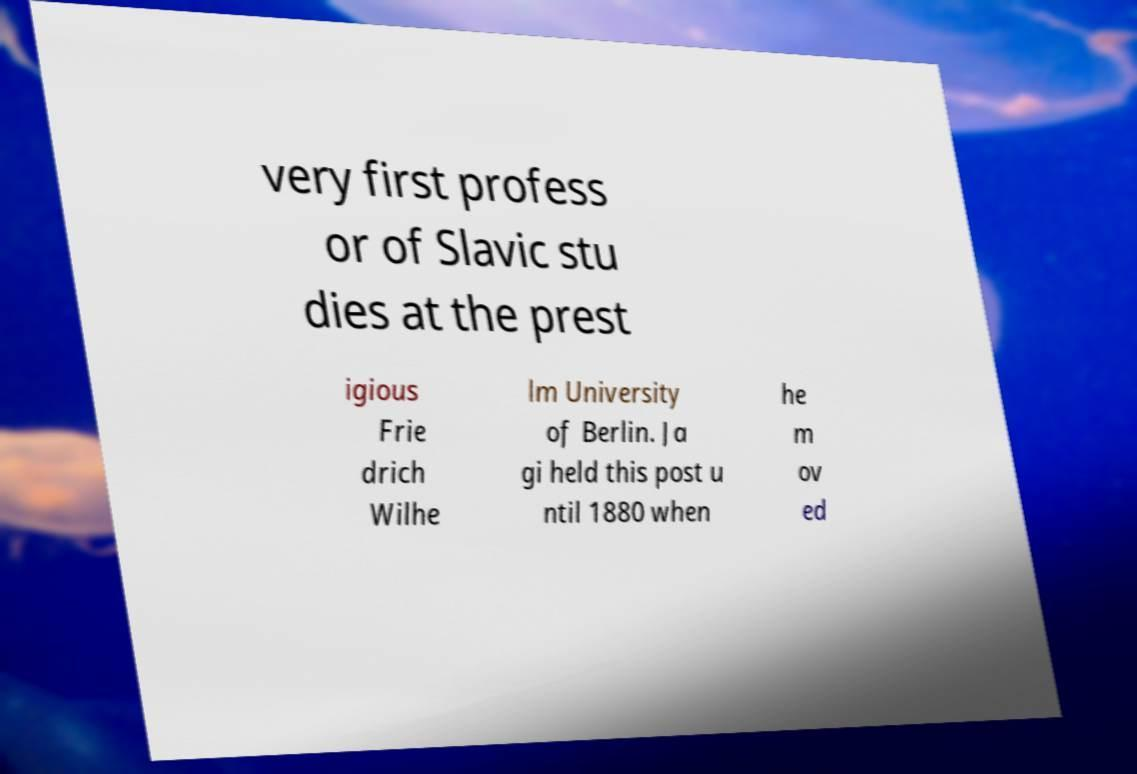What messages or text are displayed in this image? I need them in a readable, typed format. very first profess or of Slavic stu dies at the prest igious Frie drich Wilhe lm University of Berlin. Ja gi held this post u ntil 1880 when he m ov ed 